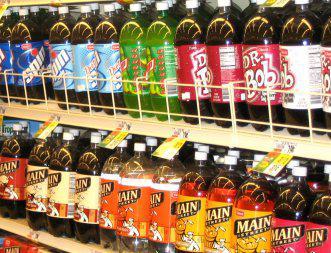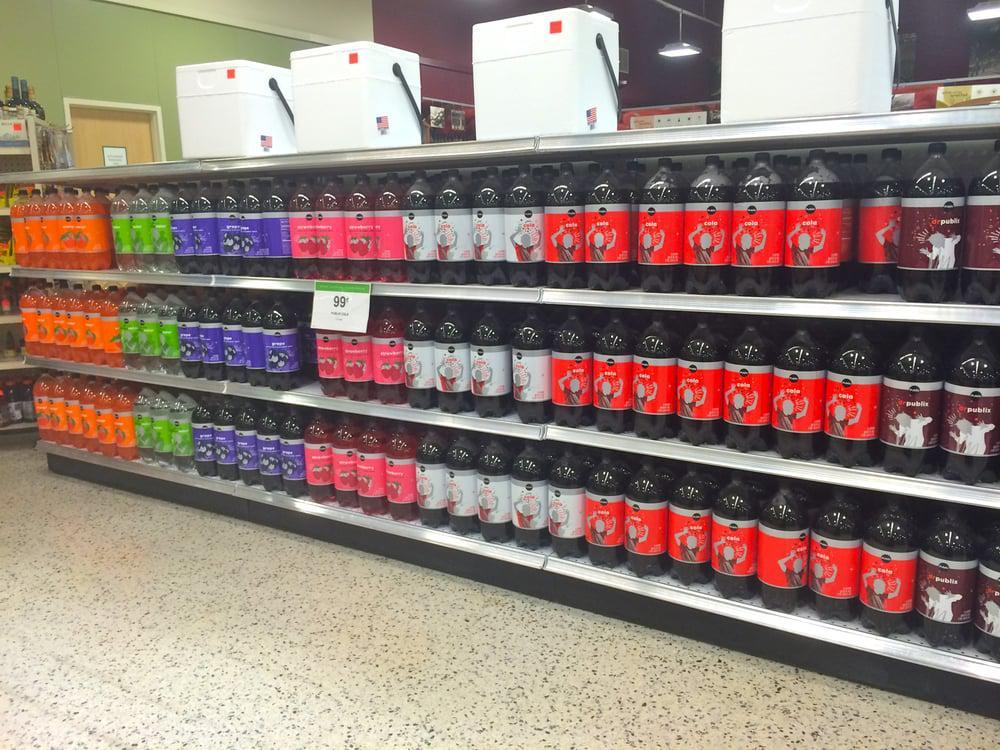The first image is the image on the left, the second image is the image on the right. For the images displayed, is the sentence "The right image contains 2 liters of soda on shelves." factually correct? Answer yes or no. Yes. The first image is the image on the left, the second image is the image on the right. For the images shown, is this caption "One image features sodas on shelves with at least one white card on a shelf edge, and the other image features sodas on shelves with yellow cards on the edges." true? Answer yes or no. Yes. 